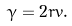<formula> <loc_0><loc_0><loc_500><loc_500>\gamma = 2 r v .</formula> 